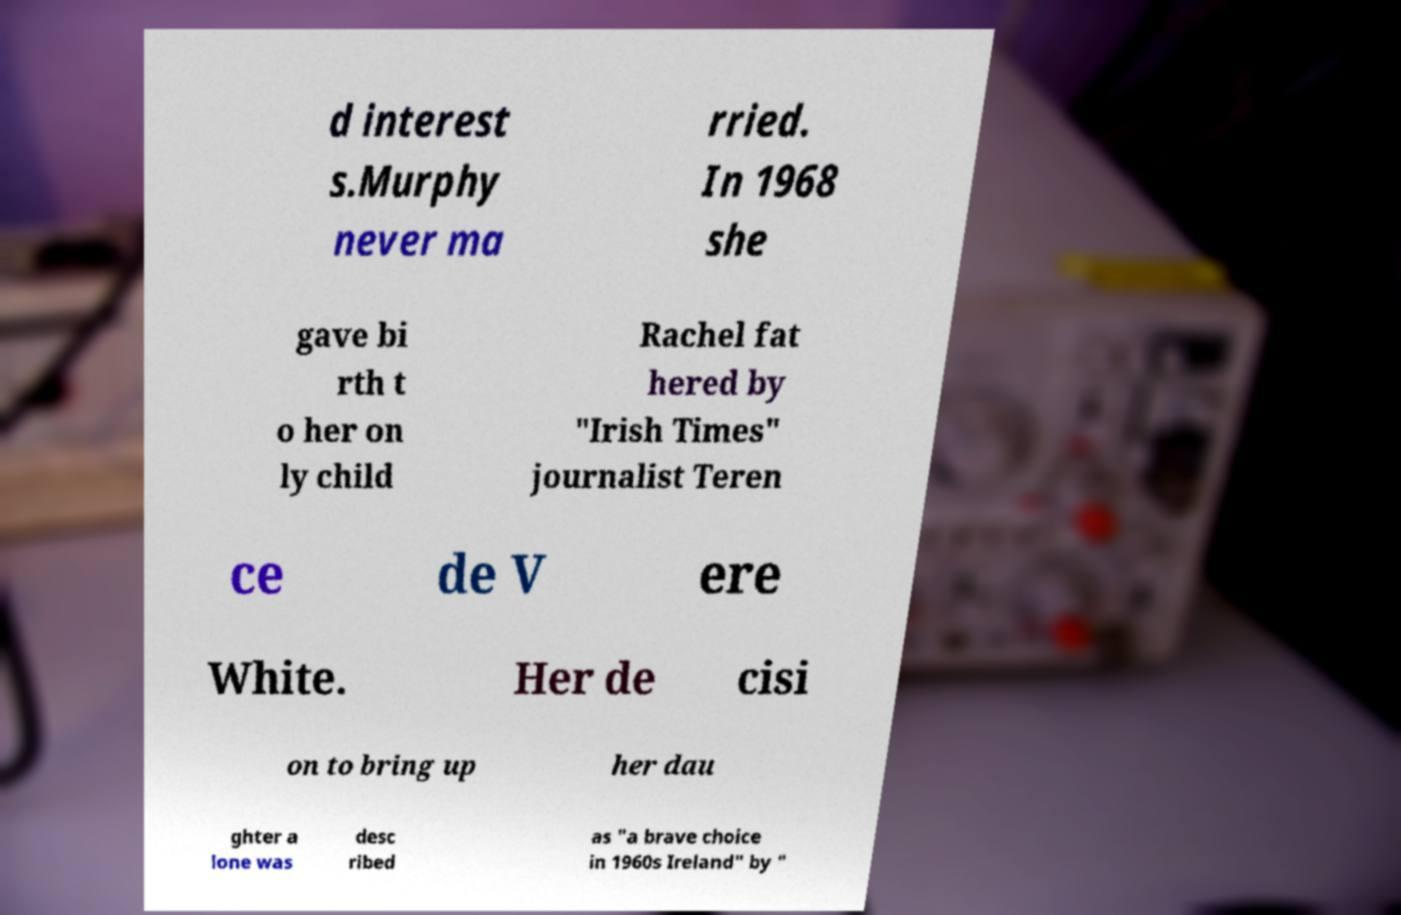Please read and relay the text visible in this image. What does it say? d interest s.Murphy never ma rried. In 1968 she gave bi rth t o her on ly child Rachel fat hered by "Irish Times" journalist Teren ce de V ere White. Her de cisi on to bring up her dau ghter a lone was desc ribed as "a brave choice in 1960s Ireland" by " 